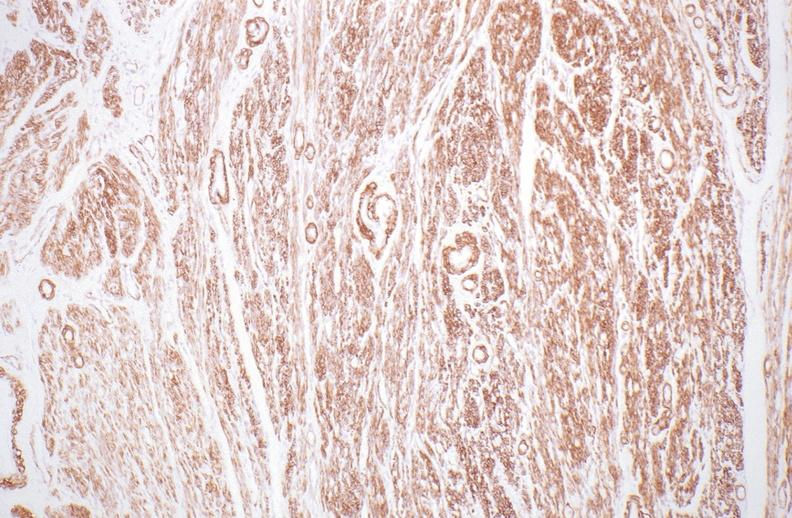s female reproductive present?
Answer the question using a single word or phrase. Yes 